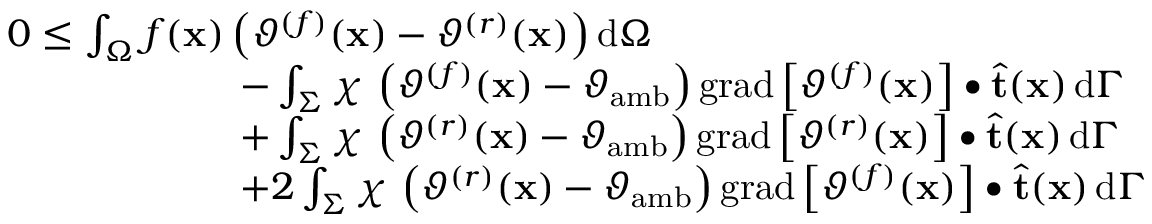<formula> <loc_0><loc_0><loc_500><loc_500>\begin{array} { r l } & { 0 \leq \int _ { \Omega } f ( x ) \left ( \vartheta ^ { ( f ) } ( x ) - \vartheta ^ { ( r ) } ( x ) \right ) d \Omega } \\ & { \quad - \int _ { \Sigma } \chi \, \left ( \vartheta ^ { ( f ) } ( x ) - \vartheta _ { a m b } \right ) g r a d \left [ \vartheta ^ { ( f ) } ( x ) \right ] \bullet \widehat { t } ( x ) \, d \Gamma } \\ & { \quad + \int _ { \Sigma } \chi \, \left ( \vartheta ^ { ( r ) } ( x ) - \vartheta _ { a m b } \right ) g r a d \left [ \vartheta ^ { ( r ) } ( x ) \right ] \bullet \widehat { t } ( x ) \, d \Gamma } \\ & { \quad + 2 \int _ { \Sigma } \chi \, \left ( \vartheta ^ { ( r ) } ( x ) - \vartheta _ { a m b } \right ) g r a d \left [ \vartheta ^ { ( f ) } ( x ) \right ] \bullet \widehat { t } ( x ) \, d \Gamma } \end{array}</formula> 